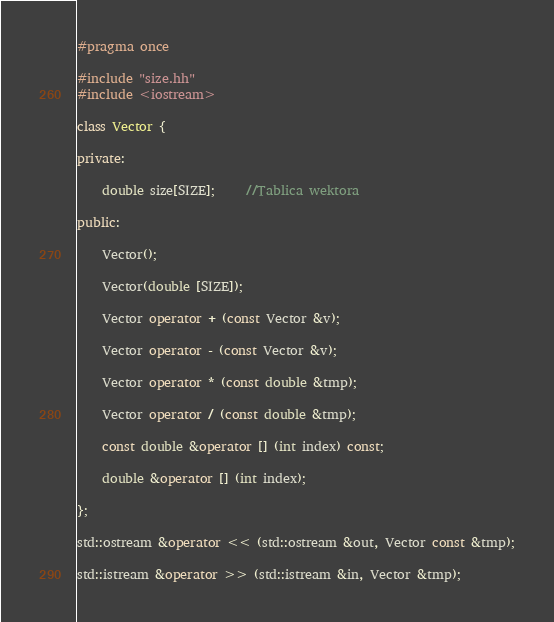Convert code to text. <code><loc_0><loc_0><loc_500><loc_500><_C++_>#pragma once

#include "size.hh"
#include <iostream>

class Vector {

private:

    double size[SIZE];     //Tablica wektora

public:

    Vector();

    Vector(double [SIZE]);

    Vector operator + (const Vector &v);

    Vector operator - (const Vector &v);

    Vector operator * (const double &tmp);

    Vector operator / (const double &tmp);

    const double &operator [] (int index) const;

    double &operator [] (int index);

};

std::ostream &operator << (std::ostream &out, Vector const &tmp);

std::istream &operator >> (std::istream &in, Vector &tmp);

</code> 